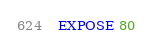<code> <loc_0><loc_0><loc_500><loc_500><_Dockerfile_>EXPOSE 80</code> 